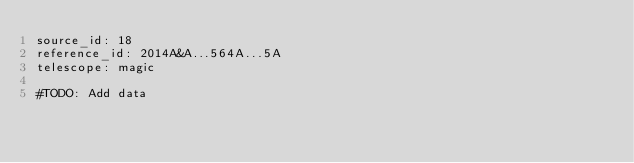Convert code to text. <code><loc_0><loc_0><loc_500><loc_500><_YAML_>source_id: 18
reference_id: 2014A&A...564A...5A
telescope: magic

#TODO: Add data
</code> 